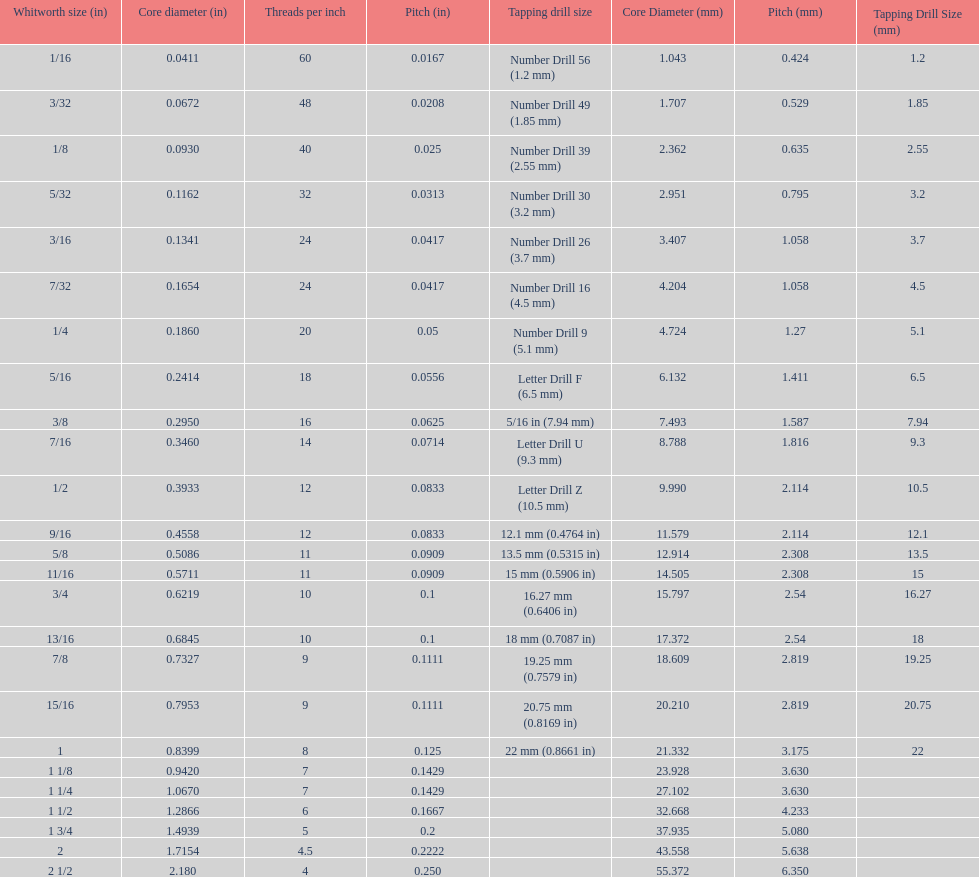Which whitworth size is the only one with 5 threads per inch? 1 3/4. Parse the table in full. {'header': ['Whitworth size (in)', 'Core diameter (in)', 'Threads per\xa0inch', 'Pitch (in)', 'Tapping drill size', 'Core Diameter (mm)', 'Pitch (mm)', 'Tapping Drill Size (mm)'], 'rows': [['1/16', '0.0411', '60', '0.0167', 'Number Drill 56 (1.2\xa0mm)', '1.043', '0.424', '1.2'], ['3/32', '0.0672', '48', '0.0208', 'Number Drill 49 (1.85\xa0mm)', '1.707', '0.529', '1.85'], ['1/8', '0.0930', '40', '0.025', 'Number Drill 39 (2.55\xa0mm)', '2.362', '0.635', '2.55'], ['5/32', '0.1162', '32', '0.0313', 'Number Drill 30 (3.2\xa0mm)', '2.951', '0.795', '3.2'], ['3/16', '0.1341', '24', '0.0417', 'Number Drill 26 (3.7\xa0mm)', '3.407', '1.058', '3.7'], ['7/32', '0.1654', '24', '0.0417', 'Number Drill 16 (4.5\xa0mm)', '4.204', '1.058', '4.5'], ['1/4', '0.1860', '20', '0.05', 'Number Drill 9 (5.1\xa0mm)', '4.724', '1.27', '5.1'], ['5/16', '0.2414', '18', '0.0556', 'Letter Drill F (6.5\xa0mm)', '6.132', '1.411', '6.5'], ['3/8', '0.2950', '16', '0.0625', '5/16\xa0in (7.94\xa0mm)', '7.493', '1.587', '7.94'], ['7/16', '0.3460', '14', '0.0714', 'Letter Drill U (9.3\xa0mm)', '8.788', '1.816', '9.3'], ['1/2', '0.3933', '12', '0.0833', 'Letter Drill Z (10.5\xa0mm)', '9.990', '2.114', '10.5'], ['9/16', '0.4558', '12', '0.0833', '12.1\xa0mm (0.4764\xa0in)', '11.579', '2.114', '12.1'], ['5/8', '0.5086', '11', '0.0909', '13.5\xa0mm (0.5315\xa0in)', '12.914', '2.308', '13.5'], ['11/16', '0.5711', '11', '0.0909', '15\xa0mm (0.5906\xa0in)', '14.505', '2.308', '15'], ['3/4', '0.6219', '10', '0.1', '16.27\xa0mm (0.6406\xa0in)', '15.797', '2.54', '16.27'], ['13/16', '0.6845', '10', '0.1', '18\xa0mm (0.7087\xa0in)', '17.372', '2.54', '18'], ['7/8', '0.7327', '9', '0.1111', '19.25\xa0mm (0.7579\xa0in)', '18.609', '2.819', '19.25'], ['15/16', '0.7953', '9', '0.1111', '20.75\xa0mm (0.8169\xa0in)', '20.210', '2.819', '20.75'], ['1', '0.8399', '8', '0.125', '22\xa0mm (0.8661\xa0in)', '21.332', '3.175', '22'], ['1 1/8', '0.9420', '7', '0.1429', '', '23.928', '3.630', ''], ['1 1/4', '1.0670', '7', '0.1429', '', '27.102', '3.630', ''], ['1 1/2', '1.2866', '6', '0.1667', '', '32.668', '4.233', ''], ['1 3/4', '1.4939', '5', '0.2', '', '37.935', '5.080', ''], ['2', '1.7154', '4.5', '0.2222', '', '43.558', '5.638', ''], ['2 1/2', '2.180', '4', '0.250', '', '55.372', '6.350', '']]} 